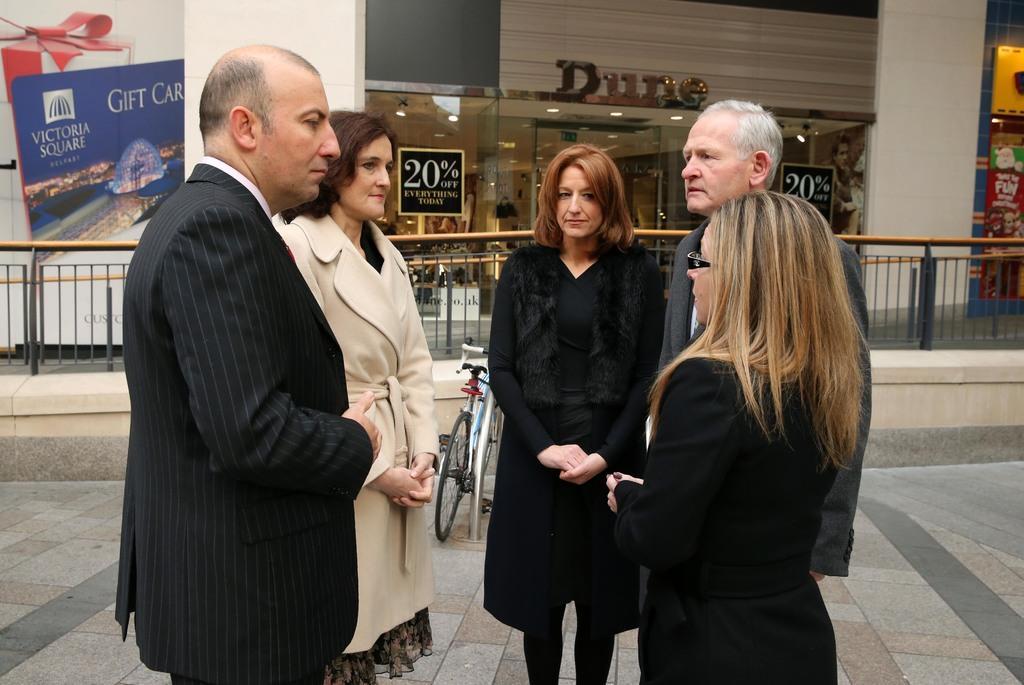Can you describe this image briefly? In this picture we can see there are five people standing on the path and behind the people there is a bicycle, iron rod, fencing and a building and on the building there is a board and a poster. In the building there are some objects and at the top there are ceiling lights. 